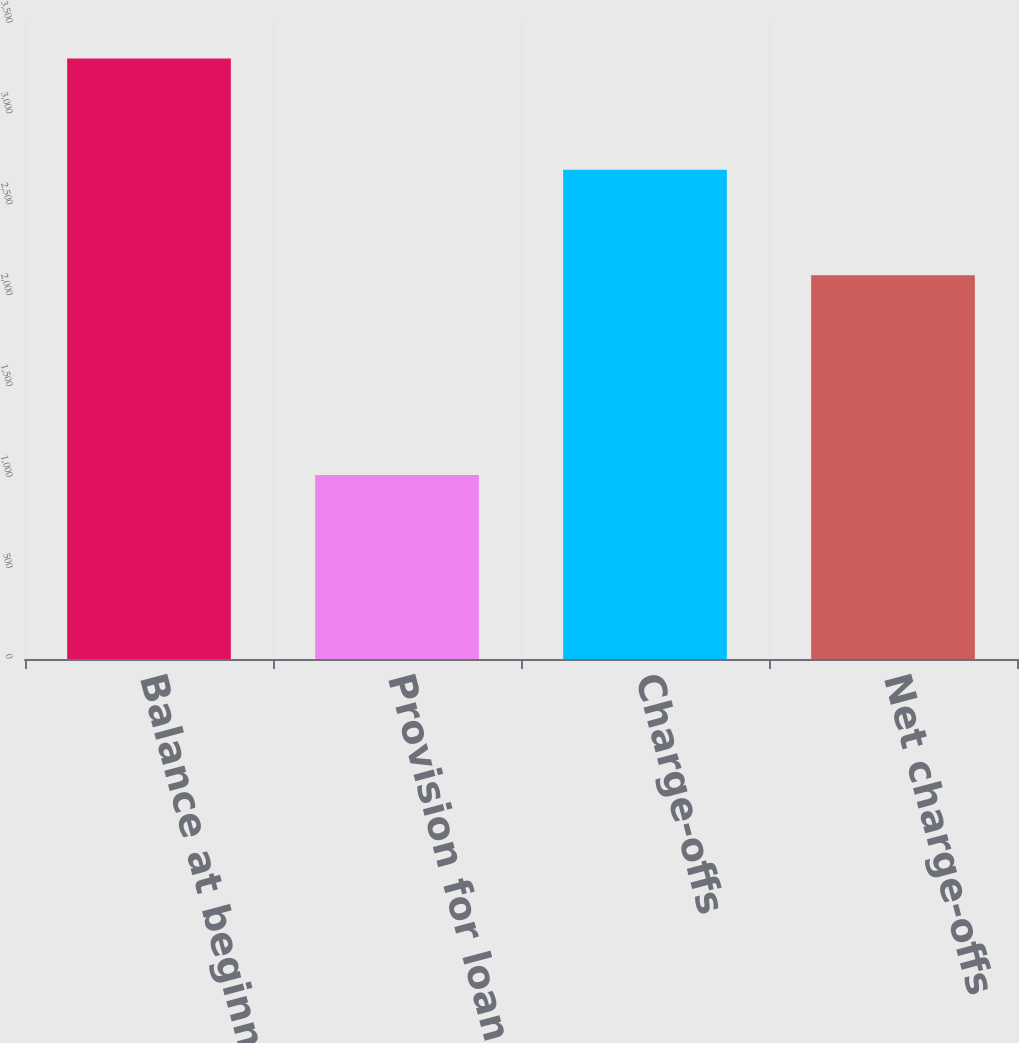Convert chart. <chart><loc_0><loc_0><loc_500><loc_500><bar_chart><fcel>Balance at beginning of period<fcel>Provision for loan losses<fcel>Charge-offs<fcel>Net charge-offs<nl><fcel>3304<fcel>1013<fcel>2693<fcel>2112<nl></chart> 